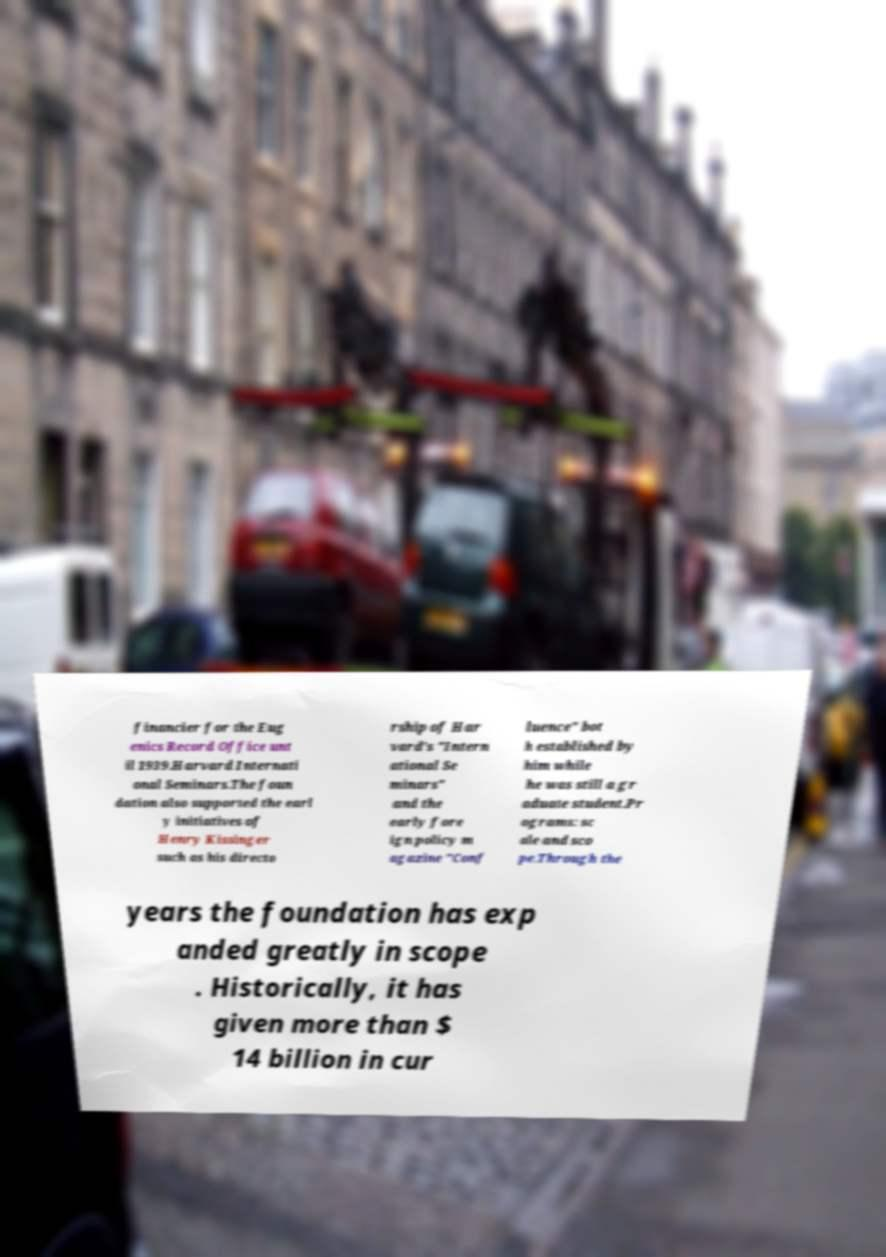Please read and relay the text visible in this image. What does it say? financier for the Eug enics Record Office unt il 1939.Harvard Internati onal Seminars.The foun dation also supported the earl y initiatives of Henry Kissinger such as his directo rship of Har vard's "Intern ational Se minars" and the early fore ign policy m agazine "Conf luence" bot h established by him while he was still a gr aduate student.Pr ograms: sc ale and sco pe.Through the years the foundation has exp anded greatly in scope . Historically, it has given more than $ 14 billion in cur 